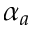Convert formula to latex. <formula><loc_0><loc_0><loc_500><loc_500>\alpha _ { a }</formula> 